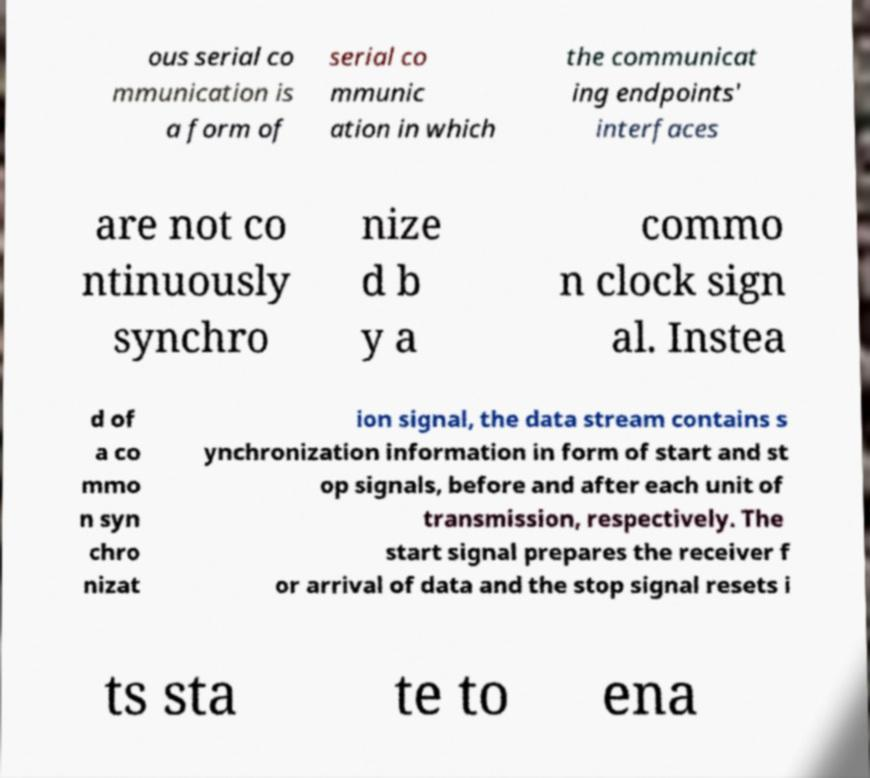Could you assist in decoding the text presented in this image and type it out clearly? ous serial co mmunication is a form of serial co mmunic ation in which the communicat ing endpoints' interfaces are not co ntinuously synchro nize d b y a commo n clock sign al. Instea d of a co mmo n syn chro nizat ion signal, the data stream contains s ynchronization information in form of start and st op signals, before and after each unit of transmission, respectively. The start signal prepares the receiver f or arrival of data and the stop signal resets i ts sta te to ena 